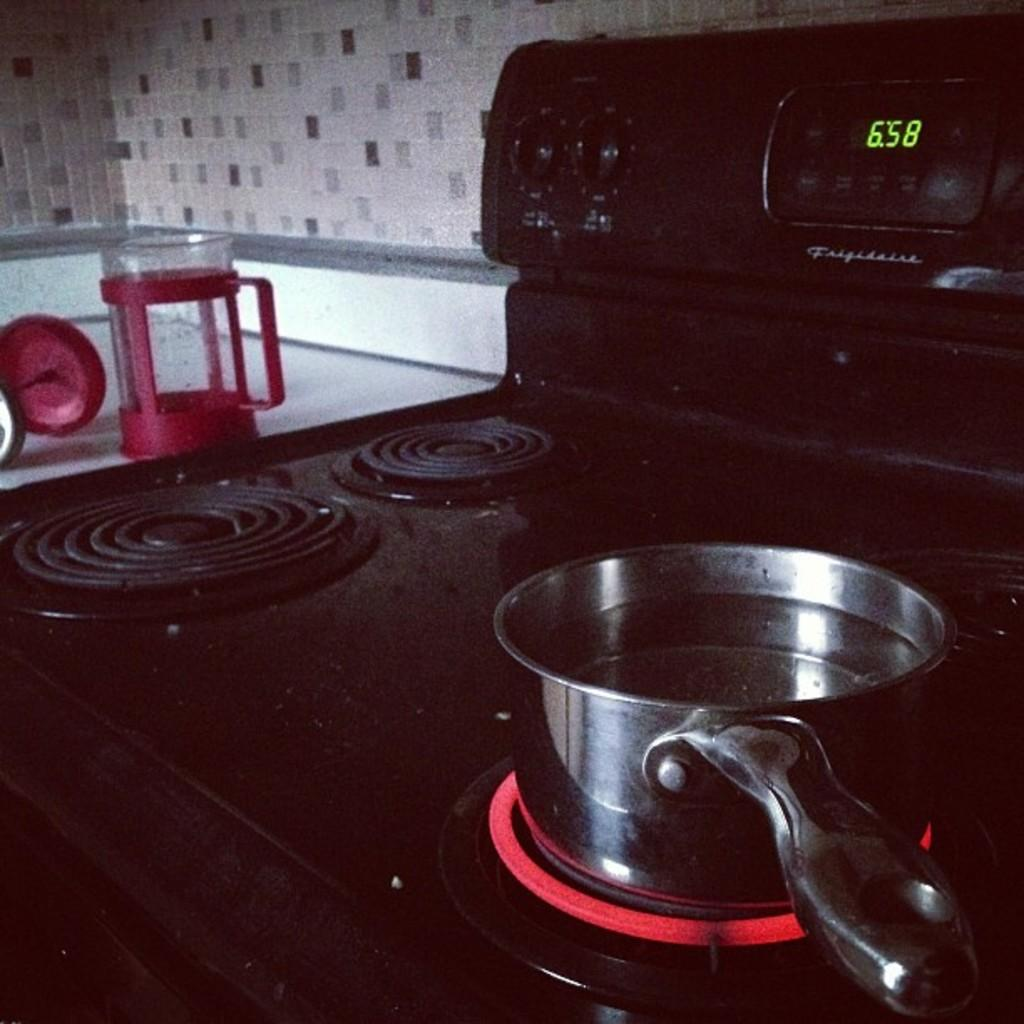<image>
Share a concise interpretation of the image provided. A pan on a stove with the burner on and the time displayed on the stove is 6:58. 